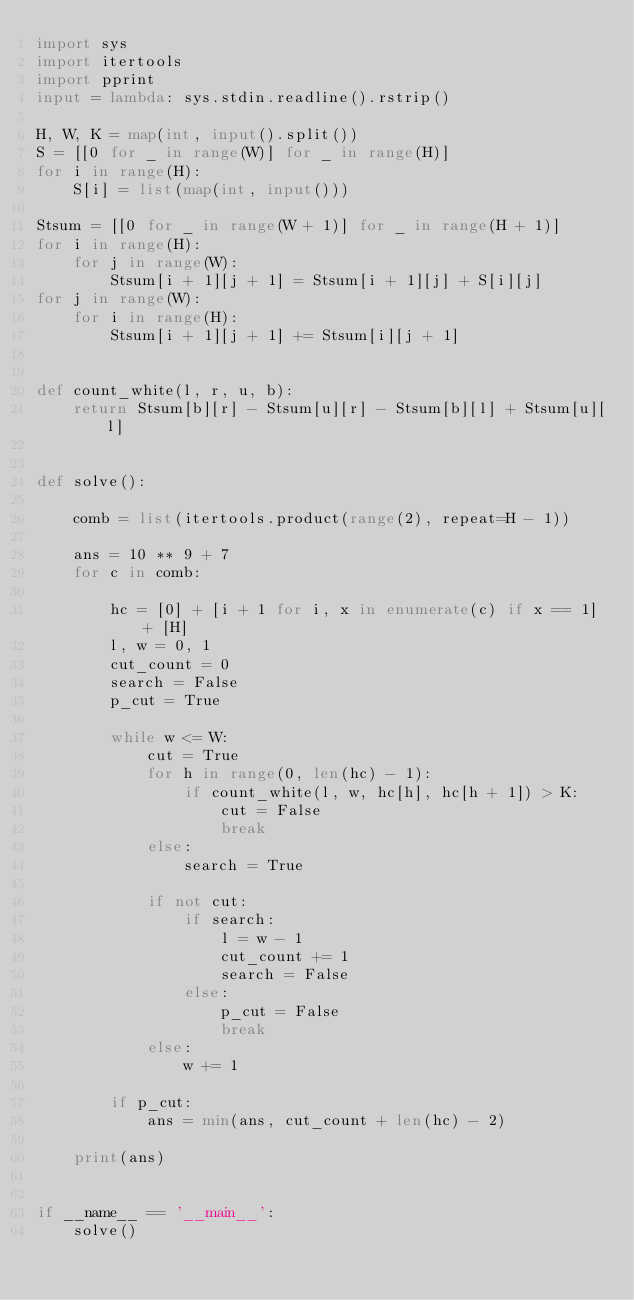Convert code to text. <code><loc_0><loc_0><loc_500><loc_500><_Python_>import sys
import itertools
import pprint
input = lambda: sys.stdin.readline().rstrip()

H, W, K = map(int, input().split())
S = [[0 for _ in range(W)] for _ in range(H)]
for i in range(H):
    S[i] = list(map(int, input()))

Stsum = [[0 for _ in range(W + 1)] for _ in range(H + 1)]
for i in range(H):
    for j in range(W):
        Stsum[i + 1][j + 1] = Stsum[i + 1][j] + S[i][j]
for j in range(W):
    for i in range(H):
        Stsum[i + 1][j + 1] += Stsum[i][j + 1]


def count_white(l, r, u, b):
    return Stsum[b][r] - Stsum[u][r] - Stsum[b][l] + Stsum[u][l]


def solve():

    comb = list(itertools.product(range(2), repeat=H - 1))

    ans = 10 ** 9 + 7
    for c in comb:

        hc = [0] + [i + 1 for i, x in enumerate(c) if x == 1] + [H]
        l, w = 0, 1
        cut_count = 0
        search = False
        p_cut = True

        while w <= W:
            cut = True
            for h in range(0, len(hc) - 1):
                if count_white(l, w, hc[h], hc[h + 1]) > K:
                    cut = False
                    break
            else:
                search = True

            if not cut:
                if search:
                    l = w - 1
                    cut_count += 1
                    search = False
                else:
                    p_cut = False
                    break
            else:
                w += 1

        if p_cut:
            ans = min(ans, cut_count + len(hc) - 2)

    print(ans)


if __name__ == '__main__':
    solve()
</code> 